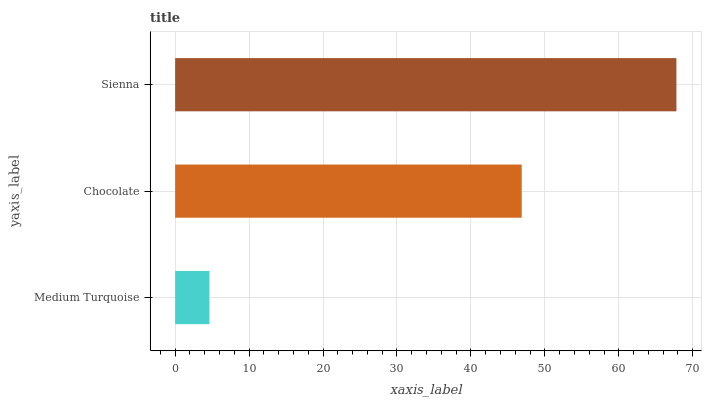Is Medium Turquoise the minimum?
Answer yes or no. Yes. Is Sienna the maximum?
Answer yes or no. Yes. Is Chocolate the minimum?
Answer yes or no. No. Is Chocolate the maximum?
Answer yes or no. No. Is Chocolate greater than Medium Turquoise?
Answer yes or no. Yes. Is Medium Turquoise less than Chocolate?
Answer yes or no. Yes. Is Medium Turquoise greater than Chocolate?
Answer yes or no. No. Is Chocolate less than Medium Turquoise?
Answer yes or no. No. Is Chocolate the high median?
Answer yes or no. Yes. Is Chocolate the low median?
Answer yes or no. Yes. Is Sienna the high median?
Answer yes or no. No. Is Medium Turquoise the low median?
Answer yes or no. No. 